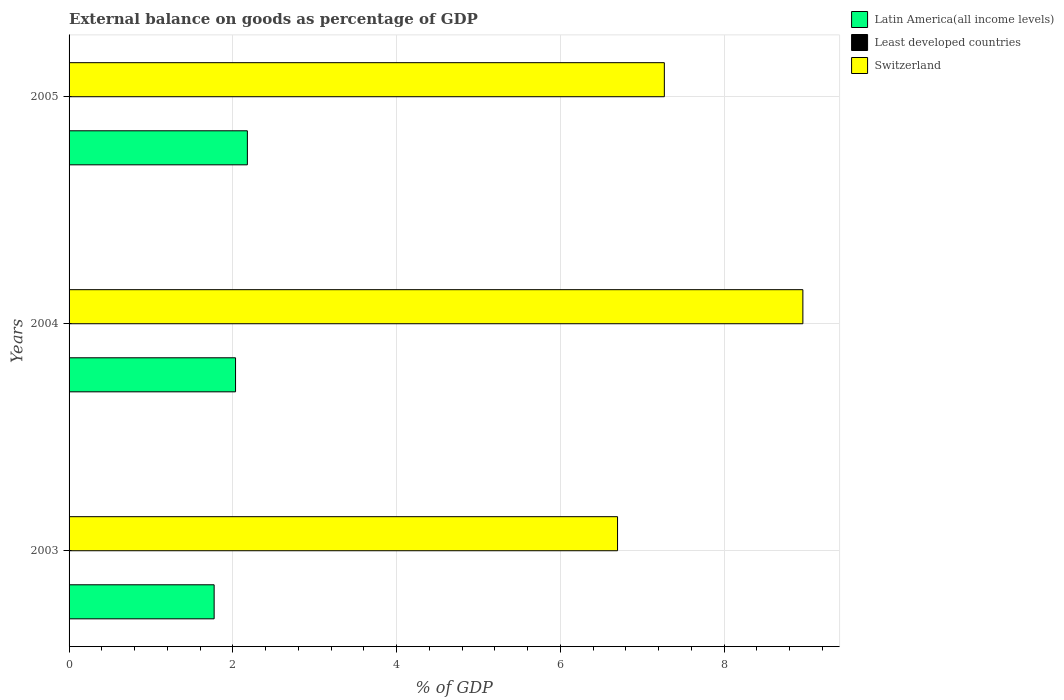How many different coloured bars are there?
Your answer should be compact. 2. How many bars are there on the 2nd tick from the top?
Make the answer very short. 2. What is the label of the 2nd group of bars from the top?
Keep it short and to the point. 2004. What is the external balance on goods as percentage of GDP in Latin America(all income levels) in 2005?
Make the answer very short. 2.18. Across all years, what is the maximum external balance on goods as percentage of GDP in Switzerland?
Ensure brevity in your answer.  8.96. Across all years, what is the minimum external balance on goods as percentage of GDP in Switzerland?
Offer a terse response. 6.7. What is the total external balance on goods as percentage of GDP in Least developed countries in the graph?
Ensure brevity in your answer.  0. What is the difference between the external balance on goods as percentage of GDP in Switzerland in 2003 and that in 2005?
Provide a short and direct response. -0.57. What is the difference between the external balance on goods as percentage of GDP in Switzerland in 2004 and the external balance on goods as percentage of GDP in Latin America(all income levels) in 2005?
Give a very brief answer. 6.78. What is the average external balance on goods as percentage of GDP in Latin America(all income levels) per year?
Your answer should be very brief. 1.99. In the year 2005, what is the difference between the external balance on goods as percentage of GDP in Latin America(all income levels) and external balance on goods as percentage of GDP in Switzerland?
Provide a short and direct response. -5.09. What is the ratio of the external balance on goods as percentage of GDP in Switzerland in 2003 to that in 2004?
Your answer should be very brief. 0.75. Is the difference between the external balance on goods as percentage of GDP in Latin America(all income levels) in 2003 and 2005 greater than the difference between the external balance on goods as percentage of GDP in Switzerland in 2003 and 2005?
Your response must be concise. Yes. What is the difference between the highest and the second highest external balance on goods as percentage of GDP in Latin America(all income levels)?
Provide a succinct answer. 0.14. What is the difference between the highest and the lowest external balance on goods as percentage of GDP in Latin America(all income levels)?
Your response must be concise. 0.41. In how many years, is the external balance on goods as percentage of GDP in Latin America(all income levels) greater than the average external balance on goods as percentage of GDP in Latin America(all income levels) taken over all years?
Offer a very short reply. 2. Is it the case that in every year, the sum of the external balance on goods as percentage of GDP in Least developed countries and external balance on goods as percentage of GDP in Latin America(all income levels) is greater than the external balance on goods as percentage of GDP in Switzerland?
Give a very brief answer. No. How many bars are there?
Provide a succinct answer. 6. How many years are there in the graph?
Ensure brevity in your answer.  3. What is the difference between two consecutive major ticks on the X-axis?
Keep it short and to the point. 2. Are the values on the major ticks of X-axis written in scientific E-notation?
Your answer should be very brief. No. Does the graph contain grids?
Give a very brief answer. Yes. Where does the legend appear in the graph?
Ensure brevity in your answer.  Top right. What is the title of the graph?
Your answer should be compact. External balance on goods as percentage of GDP. Does "Burundi" appear as one of the legend labels in the graph?
Your answer should be very brief. No. What is the label or title of the X-axis?
Offer a terse response. % of GDP. What is the label or title of the Y-axis?
Your answer should be very brief. Years. What is the % of GDP in Latin America(all income levels) in 2003?
Give a very brief answer. 1.77. What is the % of GDP in Switzerland in 2003?
Your response must be concise. 6.7. What is the % of GDP in Latin America(all income levels) in 2004?
Your response must be concise. 2.03. What is the % of GDP of Least developed countries in 2004?
Provide a short and direct response. 0. What is the % of GDP of Switzerland in 2004?
Offer a terse response. 8.96. What is the % of GDP in Latin America(all income levels) in 2005?
Keep it short and to the point. 2.18. What is the % of GDP in Switzerland in 2005?
Make the answer very short. 7.27. Across all years, what is the maximum % of GDP of Latin America(all income levels)?
Keep it short and to the point. 2.18. Across all years, what is the maximum % of GDP of Switzerland?
Provide a short and direct response. 8.96. Across all years, what is the minimum % of GDP in Latin America(all income levels)?
Your answer should be compact. 1.77. Across all years, what is the minimum % of GDP in Switzerland?
Provide a short and direct response. 6.7. What is the total % of GDP in Latin America(all income levels) in the graph?
Make the answer very short. 5.98. What is the total % of GDP of Switzerland in the graph?
Provide a short and direct response. 22.93. What is the difference between the % of GDP in Latin America(all income levels) in 2003 and that in 2004?
Your answer should be compact. -0.26. What is the difference between the % of GDP in Switzerland in 2003 and that in 2004?
Make the answer very short. -2.26. What is the difference between the % of GDP of Latin America(all income levels) in 2003 and that in 2005?
Your answer should be very brief. -0.41. What is the difference between the % of GDP in Switzerland in 2003 and that in 2005?
Make the answer very short. -0.57. What is the difference between the % of GDP in Latin America(all income levels) in 2004 and that in 2005?
Offer a very short reply. -0.14. What is the difference between the % of GDP of Switzerland in 2004 and that in 2005?
Your response must be concise. 1.69. What is the difference between the % of GDP of Latin America(all income levels) in 2003 and the % of GDP of Switzerland in 2004?
Your response must be concise. -7.19. What is the difference between the % of GDP of Latin America(all income levels) in 2003 and the % of GDP of Switzerland in 2005?
Ensure brevity in your answer.  -5.5. What is the difference between the % of GDP of Latin America(all income levels) in 2004 and the % of GDP of Switzerland in 2005?
Offer a terse response. -5.24. What is the average % of GDP in Latin America(all income levels) per year?
Offer a very short reply. 1.99. What is the average % of GDP of Least developed countries per year?
Provide a short and direct response. 0. What is the average % of GDP of Switzerland per year?
Offer a very short reply. 7.64. In the year 2003, what is the difference between the % of GDP in Latin America(all income levels) and % of GDP in Switzerland?
Offer a terse response. -4.93. In the year 2004, what is the difference between the % of GDP of Latin America(all income levels) and % of GDP of Switzerland?
Your answer should be compact. -6.93. In the year 2005, what is the difference between the % of GDP in Latin America(all income levels) and % of GDP in Switzerland?
Provide a short and direct response. -5.09. What is the ratio of the % of GDP in Latin America(all income levels) in 2003 to that in 2004?
Your answer should be compact. 0.87. What is the ratio of the % of GDP of Switzerland in 2003 to that in 2004?
Provide a short and direct response. 0.75. What is the ratio of the % of GDP in Latin America(all income levels) in 2003 to that in 2005?
Provide a short and direct response. 0.81. What is the ratio of the % of GDP in Switzerland in 2003 to that in 2005?
Provide a short and direct response. 0.92. What is the ratio of the % of GDP of Latin America(all income levels) in 2004 to that in 2005?
Offer a very short reply. 0.93. What is the ratio of the % of GDP of Switzerland in 2004 to that in 2005?
Offer a very short reply. 1.23. What is the difference between the highest and the second highest % of GDP of Latin America(all income levels)?
Make the answer very short. 0.14. What is the difference between the highest and the second highest % of GDP of Switzerland?
Make the answer very short. 1.69. What is the difference between the highest and the lowest % of GDP in Latin America(all income levels)?
Keep it short and to the point. 0.41. What is the difference between the highest and the lowest % of GDP in Switzerland?
Your response must be concise. 2.26. 